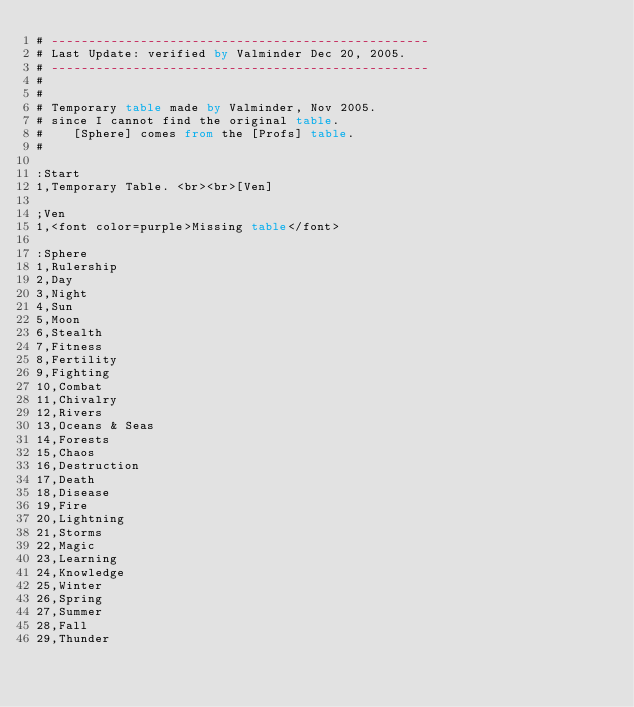<code> <loc_0><loc_0><loc_500><loc_500><_SQL_># ---------------------------------------------------
# Last Update: verified by Valminder Dec 20, 2005.
# ---------------------------------------------------
#
#
# Temporary table made by Valminder, Nov 2005.
# since I cannot find the original table.
#    [Sphere] comes from the [Profs] table.
#

:Start
1,Temporary Table. <br><br>[Ven]

;Ven
1,<font color=purple>Missing table</font>

:Sphere
1,Rulership
2,Day
3,Night
4,Sun
5,Moon
6,Stealth
7,Fitness
8,Fertility
9,Fighting
10,Combat
11,Chivalry
12,Rivers
13,Oceans & Seas
14,Forests
15,Chaos
16,Destruction
17,Death
18,Disease
19,Fire
20,Lightning
21,Storms
22,Magic
23,Learning
24,Knowledge
25,Winter
26,Spring
27,Summer
28,Fall
29,Thunder
</code> 